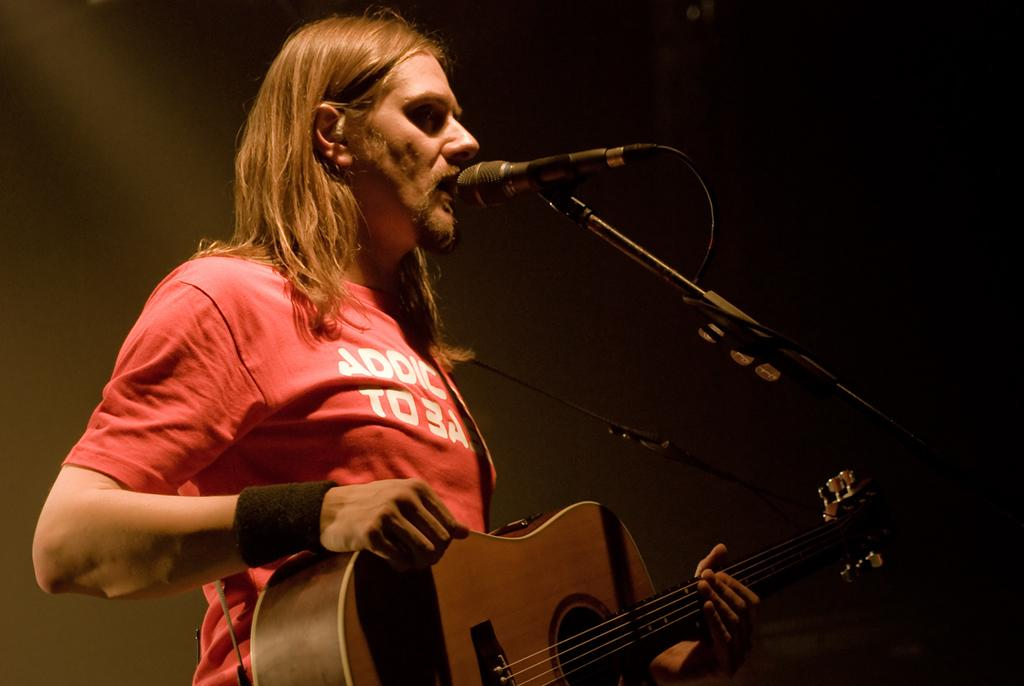Who is the main subject in the image? There is a person in the center of the image. What is the person doing in the image? The person is singing and playing a guitar. What object is in front of the person? There is a microphone in front of the person. Can you see any insects crawling on the guitar strings in the image? There are no insects visible in the image, as it focuses on the person singing and playing a guitar. 